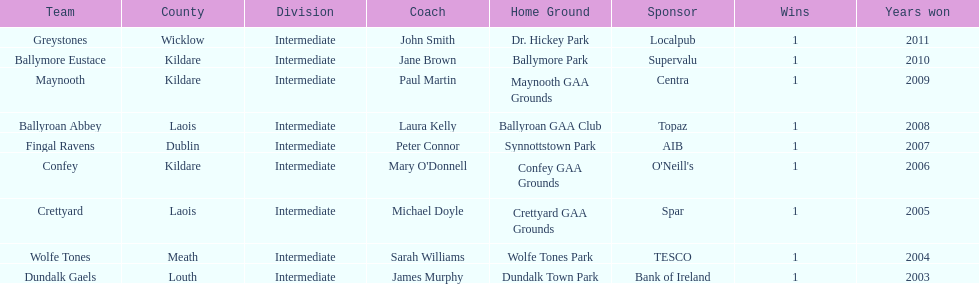How many wins does greystones have? 1. 